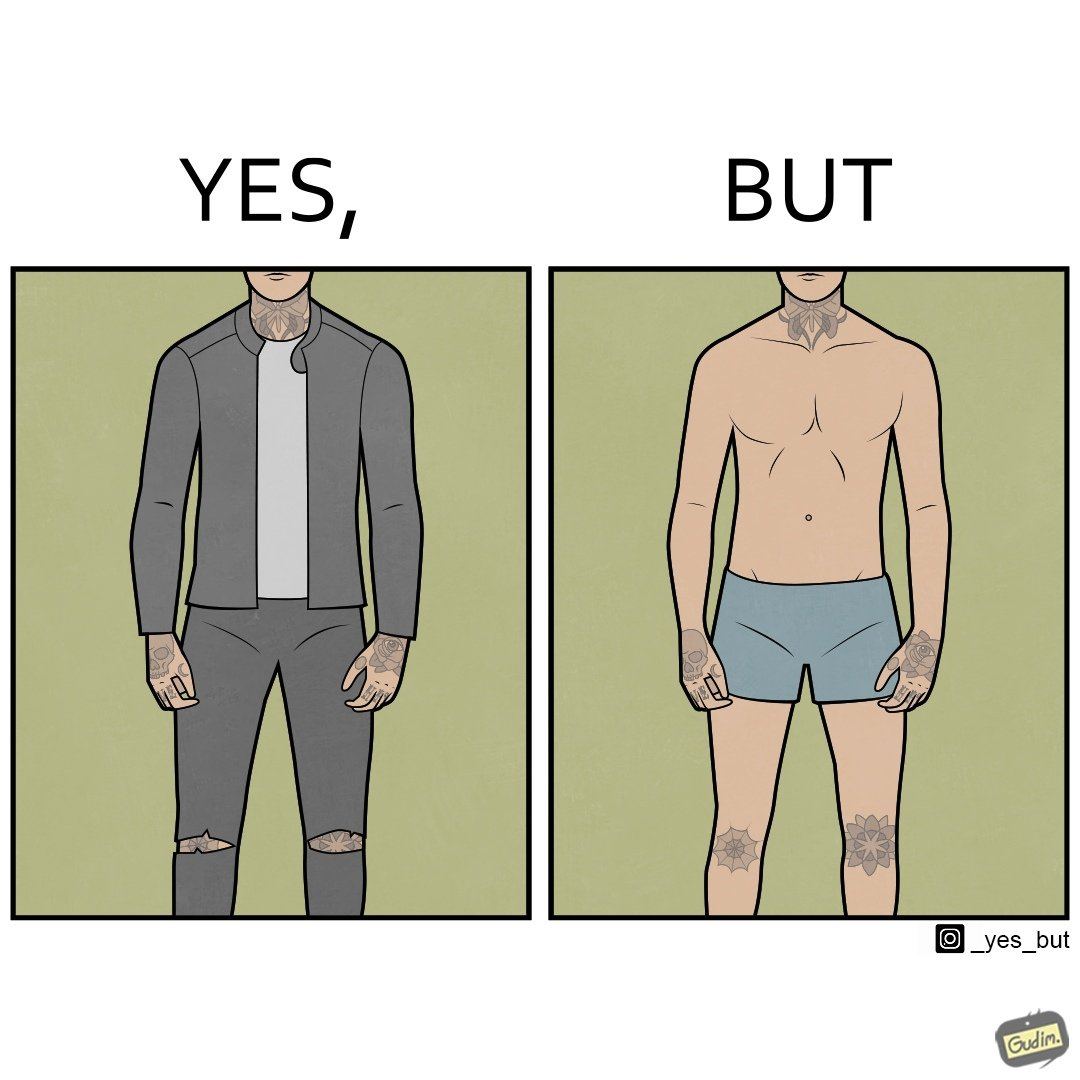Would you classify this image as satirical? Yes, this image is satirical. 